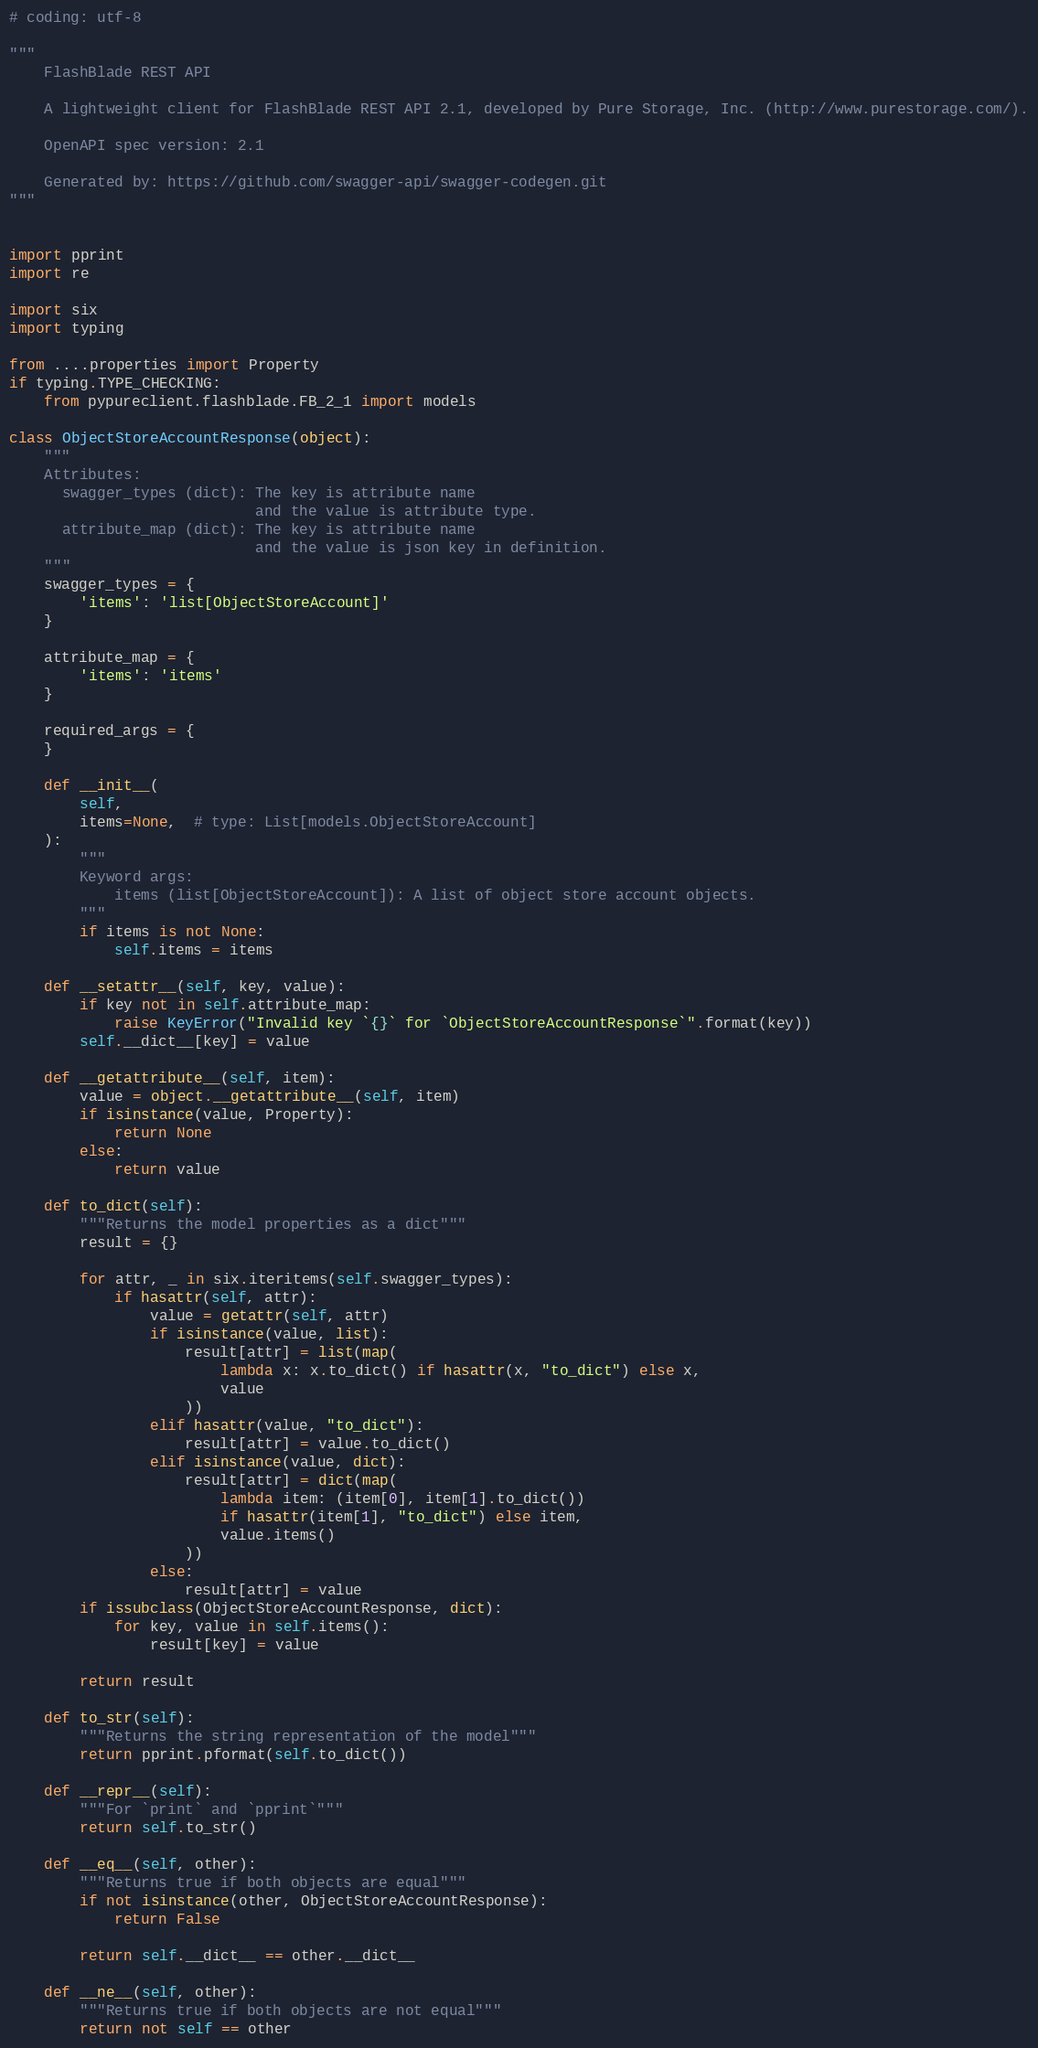Convert code to text. <code><loc_0><loc_0><loc_500><loc_500><_Python_># coding: utf-8

"""
    FlashBlade REST API

    A lightweight client for FlashBlade REST API 2.1, developed by Pure Storage, Inc. (http://www.purestorage.com/).

    OpenAPI spec version: 2.1
    
    Generated by: https://github.com/swagger-api/swagger-codegen.git
"""


import pprint
import re

import six
import typing

from ....properties import Property
if typing.TYPE_CHECKING:
    from pypureclient.flashblade.FB_2_1 import models

class ObjectStoreAccountResponse(object):
    """
    Attributes:
      swagger_types (dict): The key is attribute name
                            and the value is attribute type.
      attribute_map (dict): The key is attribute name
                            and the value is json key in definition.
    """
    swagger_types = {
        'items': 'list[ObjectStoreAccount]'
    }

    attribute_map = {
        'items': 'items'
    }

    required_args = {
    }

    def __init__(
        self,
        items=None,  # type: List[models.ObjectStoreAccount]
    ):
        """
        Keyword args:
            items (list[ObjectStoreAccount]): A list of object store account objects.
        """
        if items is not None:
            self.items = items

    def __setattr__(self, key, value):
        if key not in self.attribute_map:
            raise KeyError("Invalid key `{}` for `ObjectStoreAccountResponse`".format(key))
        self.__dict__[key] = value

    def __getattribute__(self, item):
        value = object.__getattribute__(self, item)
        if isinstance(value, Property):
            return None
        else:
            return value

    def to_dict(self):
        """Returns the model properties as a dict"""
        result = {}

        for attr, _ in six.iteritems(self.swagger_types):
            if hasattr(self, attr):
                value = getattr(self, attr)
                if isinstance(value, list):
                    result[attr] = list(map(
                        lambda x: x.to_dict() if hasattr(x, "to_dict") else x,
                        value
                    ))
                elif hasattr(value, "to_dict"):
                    result[attr] = value.to_dict()
                elif isinstance(value, dict):
                    result[attr] = dict(map(
                        lambda item: (item[0], item[1].to_dict())
                        if hasattr(item[1], "to_dict") else item,
                        value.items()
                    ))
                else:
                    result[attr] = value
        if issubclass(ObjectStoreAccountResponse, dict):
            for key, value in self.items():
                result[key] = value

        return result

    def to_str(self):
        """Returns the string representation of the model"""
        return pprint.pformat(self.to_dict())

    def __repr__(self):
        """For `print` and `pprint`"""
        return self.to_str()

    def __eq__(self, other):
        """Returns true if both objects are equal"""
        if not isinstance(other, ObjectStoreAccountResponse):
            return False

        return self.__dict__ == other.__dict__

    def __ne__(self, other):
        """Returns true if both objects are not equal"""
        return not self == other
</code> 